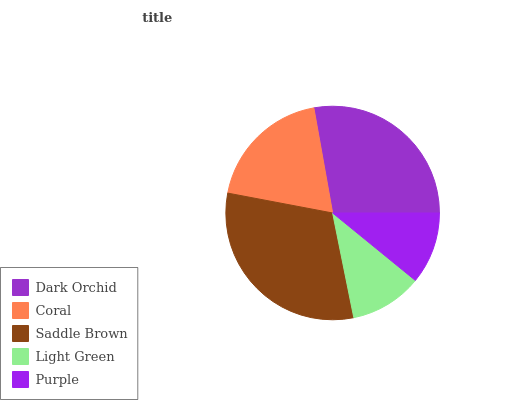Is Purple the minimum?
Answer yes or no. Yes. Is Saddle Brown the maximum?
Answer yes or no. Yes. Is Coral the minimum?
Answer yes or no. No. Is Coral the maximum?
Answer yes or no. No. Is Dark Orchid greater than Coral?
Answer yes or no. Yes. Is Coral less than Dark Orchid?
Answer yes or no. Yes. Is Coral greater than Dark Orchid?
Answer yes or no. No. Is Dark Orchid less than Coral?
Answer yes or no. No. Is Coral the high median?
Answer yes or no. Yes. Is Coral the low median?
Answer yes or no. Yes. Is Dark Orchid the high median?
Answer yes or no. No. Is Saddle Brown the low median?
Answer yes or no. No. 